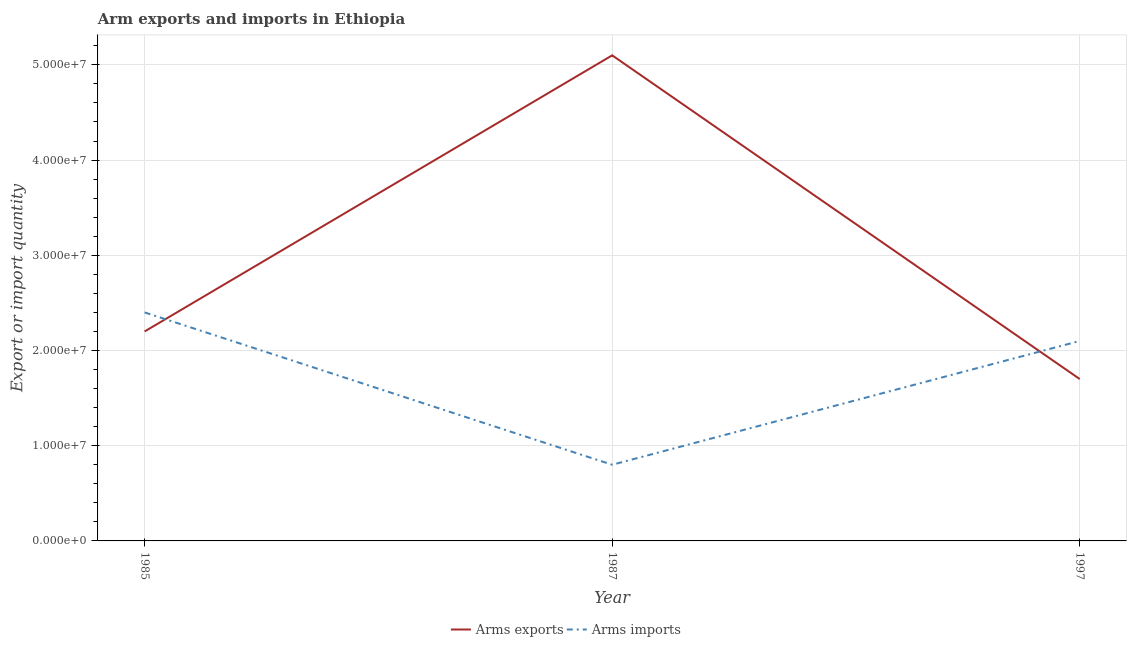Is the number of lines equal to the number of legend labels?
Provide a short and direct response. Yes. What is the arms imports in 1987?
Your answer should be very brief. 8.00e+06. Across all years, what is the maximum arms exports?
Keep it short and to the point. 5.10e+07. Across all years, what is the minimum arms imports?
Keep it short and to the point. 8.00e+06. What is the total arms imports in the graph?
Offer a terse response. 5.30e+07. What is the difference between the arms imports in 1985 and that in 1997?
Ensure brevity in your answer.  3.00e+06. What is the difference between the arms imports in 1985 and the arms exports in 1987?
Ensure brevity in your answer.  -2.70e+07. What is the average arms exports per year?
Your answer should be compact. 3.00e+07. In the year 1997, what is the difference between the arms imports and arms exports?
Your answer should be very brief. 4.00e+06. What is the ratio of the arms imports in 1987 to that in 1997?
Your answer should be very brief. 0.38. Is the arms imports in 1985 less than that in 1987?
Offer a very short reply. No. Is the difference between the arms exports in 1985 and 1987 greater than the difference between the arms imports in 1985 and 1987?
Provide a short and direct response. No. What is the difference between the highest and the lowest arms imports?
Your response must be concise. 1.60e+07. In how many years, is the arms imports greater than the average arms imports taken over all years?
Give a very brief answer. 2. Is the sum of the arms imports in 1987 and 1997 greater than the maximum arms exports across all years?
Your answer should be very brief. No. Does the arms imports monotonically increase over the years?
Ensure brevity in your answer.  No. Is the arms imports strictly greater than the arms exports over the years?
Offer a terse response. No. Is the arms exports strictly less than the arms imports over the years?
Provide a succinct answer. No. How many years are there in the graph?
Your answer should be very brief. 3. What is the difference between two consecutive major ticks on the Y-axis?
Give a very brief answer. 1.00e+07. Does the graph contain grids?
Provide a short and direct response. Yes. How many legend labels are there?
Offer a terse response. 2. How are the legend labels stacked?
Make the answer very short. Horizontal. What is the title of the graph?
Give a very brief answer. Arm exports and imports in Ethiopia. Does "Fixed telephone" appear as one of the legend labels in the graph?
Your answer should be compact. No. What is the label or title of the Y-axis?
Ensure brevity in your answer.  Export or import quantity. What is the Export or import quantity of Arms exports in 1985?
Provide a succinct answer. 2.20e+07. What is the Export or import quantity in Arms imports in 1985?
Provide a succinct answer. 2.40e+07. What is the Export or import quantity of Arms exports in 1987?
Make the answer very short. 5.10e+07. What is the Export or import quantity in Arms imports in 1987?
Your answer should be very brief. 8.00e+06. What is the Export or import quantity in Arms exports in 1997?
Offer a terse response. 1.70e+07. What is the Export or import quantity of Arms imports in 1997?
Offer a very short reply. 2.10e+07. Across all years, what is the maximum Export or import quantity in Arms exports?
Your response must be concise. 5.10e+07. Across all years, what is the maximum Export or import quantity of Arms imports?
Your answer should be compact. 2.40e+07. Across all years, what is the minimum Export or import quantity in Arms exports?
Keep it short and to the point. 1.70e+07. What is the total Export or import quantity in Arms exports in the graph?
Provide a short and direct response. 9.00e+07. What is the total Export or import quantity in Arms imports in the graph?
Ensure brevity in your answer.  5.30e+07. What is the difference between the Export or import quantity in Arms exports in 1985 and that in 1987?
Make the answer very short. -2.90e+07. What is the difference between the Export or import quantity in Arms imports in 1985 and that in 1987?
Keep it short and to the point. 1.60e+07. What is the difference between the Export or import quantity in Arms exports in 1985 and that in 1997?
Provide a short and direct response. 5.00e+06. What is the difference between the Export or import quantity in Arms imports in 1985 and that in 1997?
Provide a short and direct response. 3.00e+06. What is the difference between the Export or import quantity of Arms exports in 1987 and that in 1997?
Keep it short and to the point. 3.40e+07. What is the difference between the Export or import quantity of Arms imports in 1987 and that in 1997?
Provide a short and direct response. -1.30e+07. What is the difference between the Export or import quantity in Arms exports in 1985 and the Export or import quantity in Arms imports in 1987?
Offer a terse response. 1.40e+07. What is the difference between the Export or import quantity in Arms exports in 1987 and the Export or import quantity in Arms imports in 1997?
Offer a very short reply. 3.00e+07. What is the average Export or import quantity in Arms exports per year?
Offer a terse response. 3.00e+07. What is the average Export or import quantity in Arms imports per year?
Provide a succinct answer. 1.77e+07. In the year 1987, what is the difference between the Export or import quantity of Arms exports and Export or import quantity of Arms imports?
Your answer should be very brief. 4.30e+07. In the year 1997, what is the difference between the Export or import quantity of Arms exports and Export or import quantity of Arms imports?
Provide a short and direct response. -4.00e+06. What is the ratio of the Export or import quantity in Arms exports in 1985 to that in 1987?
Offer a very short reply. 0.43. What is the ratio of the Export or import quantity in Arms exports in 1985 to that in 1997?
Offer a very short reply. 1.29. What is the ratio of the Export or import quantity in Arms imports in 1985 to that in 1997?
Your answer should be very brief. 1.14. What is the ratio of the Export or import quantity in Arms imports in 1987 to that in 1997?
Provide a succinct answer. 0.38. What is the difference between the highest and the second highest Export or import quantity in Arms exports?
Give a very brief answer. 2.90e+07. What is the difference between the highest and the second highest Export or import quantity of Arms imports?
Provide a succinct answer. 3.00e+06. What is the difference between the highest and the lowest Export or import quantity in Arms exports?
Offer a very short reply. 3.40e+07. What is the difference between the highest and the lowest Export or import quantity of Arms imports?
Offer a very short reply. 1.60e+07. 